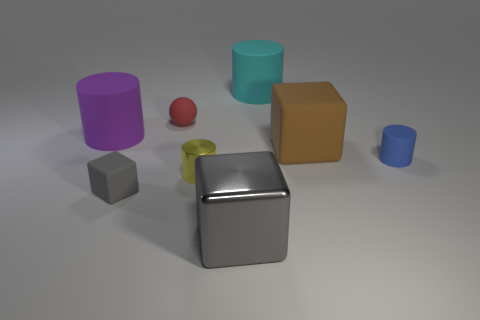What is the color of the cube that is both in front of the blue rubber cylinder and behind the large gray metallic thing?
Your answer should be compact. Gray. There is a matte block that is behind the blue matte cylinder; does it have the same size as the rubber object behind the small red object?
Ensure brevity in your answer.  Yes. What number of other things are the same size as the red object?
Provide a short and direct response. 3. There is a tiny object that is on the right side of the tiny yellow metallic object; what number of cylinders are on the left side of it?
Offer a very short reply. 3. Is the number of big brown things on the left side of the brown matte thing less than the number of purple rubber cubes?
Offer a very short reply. No. There is a big object on the left side of the large object that is in front of the large block that is to the right of the cyan rubber cylinder; what is its shape?
Provide a succinct answer. Cylinder. Is the big cyan matte object the same shape as the red matte thing?
Provide a succinct answer. No. What number of other objects are the same shape as the tiny shiny thing?
Your response must be concise. 3. The cube that is the same size as the gray metallic object is what color?
Offer a very short reply. Brown. Are there an equal number of cyan rubber cylinders that are left of the yellow metallic object and blue matte cylinders?
Offer a terse response. No. 